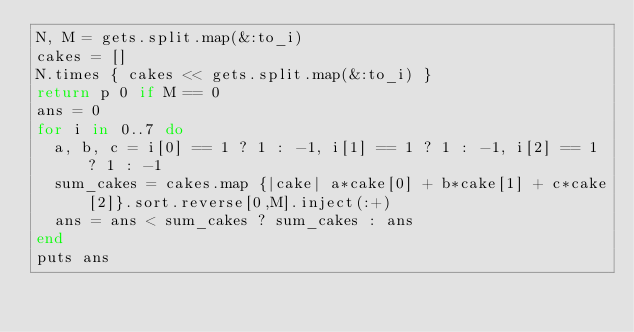Convert code to text. <code><loc_0><loc_0><loc_500><loc_500><_Ruby_>N, M = gets.split.map(&:to_i)
cakes = []
N.times { cakes << gets.split.map(&:to_i) } 
return p 0 if M == 0
ans = 0
for i in 0..7 do
  a, b, c = i[0] == 1 ? 1 : -1, i[1] == 1 ? 1 : -1, i[2] == 1 ? 1 : -1 
  sum_cakes = cakes.map {|cake| a*cake[0] + b*cake[1] + c*cake[2]}.sort.reverse[0,M].inject(:+)
  ans = ans < sum_cakes ? sum_cakes : ans
end
puts ans</code> 